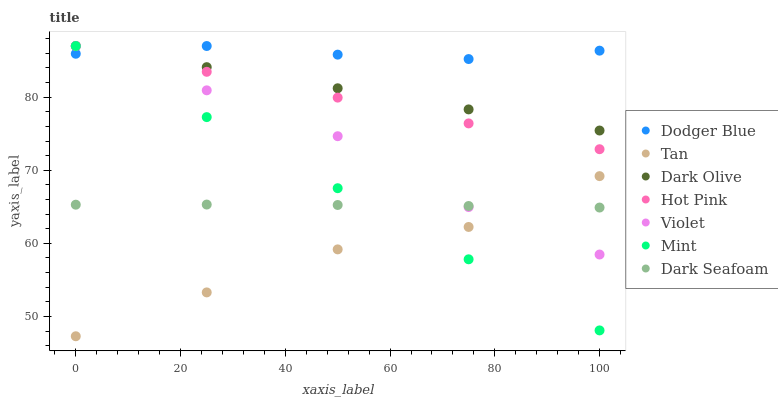Does Tan have the minimum area under the curve?
Answer yes or no. Yes. Does Dodger Blue have the maximum area under the curve?
Answer yes or no. Yes. Does Dark Olive have the minimum area under the curve?
Answer yes or no. No. Does Dark Olive have the maximum area under the curve?
Answer yes or no. No. Is Mint the smoothest?
Answer yes or no. Yes. Is Violet the roughest?
Answer yes or no. Yes. Is Dark Olive the smoothest?
Answer yes or no. No. Is Dark Olive the roughest?
Answer yes or no. No. Does Tan have the lowest value?
Answer yes or no. Yes. Does Dark Olive have the lowest value?
Answer yes or no. No. Does Mint have the highest value?
Answer yes or no. Yes. Does Dark Seafoam have the highest value?
Answer yes or no. No. Is Dark Seafoam less than Dark Olive?
Answer yes or no. Yes. Is Dark Olive greater than Tan?
Answer yes or no. Yes. Does Dodger Blue intersect Hot Pink?
Answer yes or no. Yes. Is Dodger Blue less than Hot Pink?
Answer yes or no. No. Is Dodger Blue greater than Hot Pink?
Answer yes or no. No. Does Dark Seafoam intersect Dark Olive?
Answer yes or no. No. 